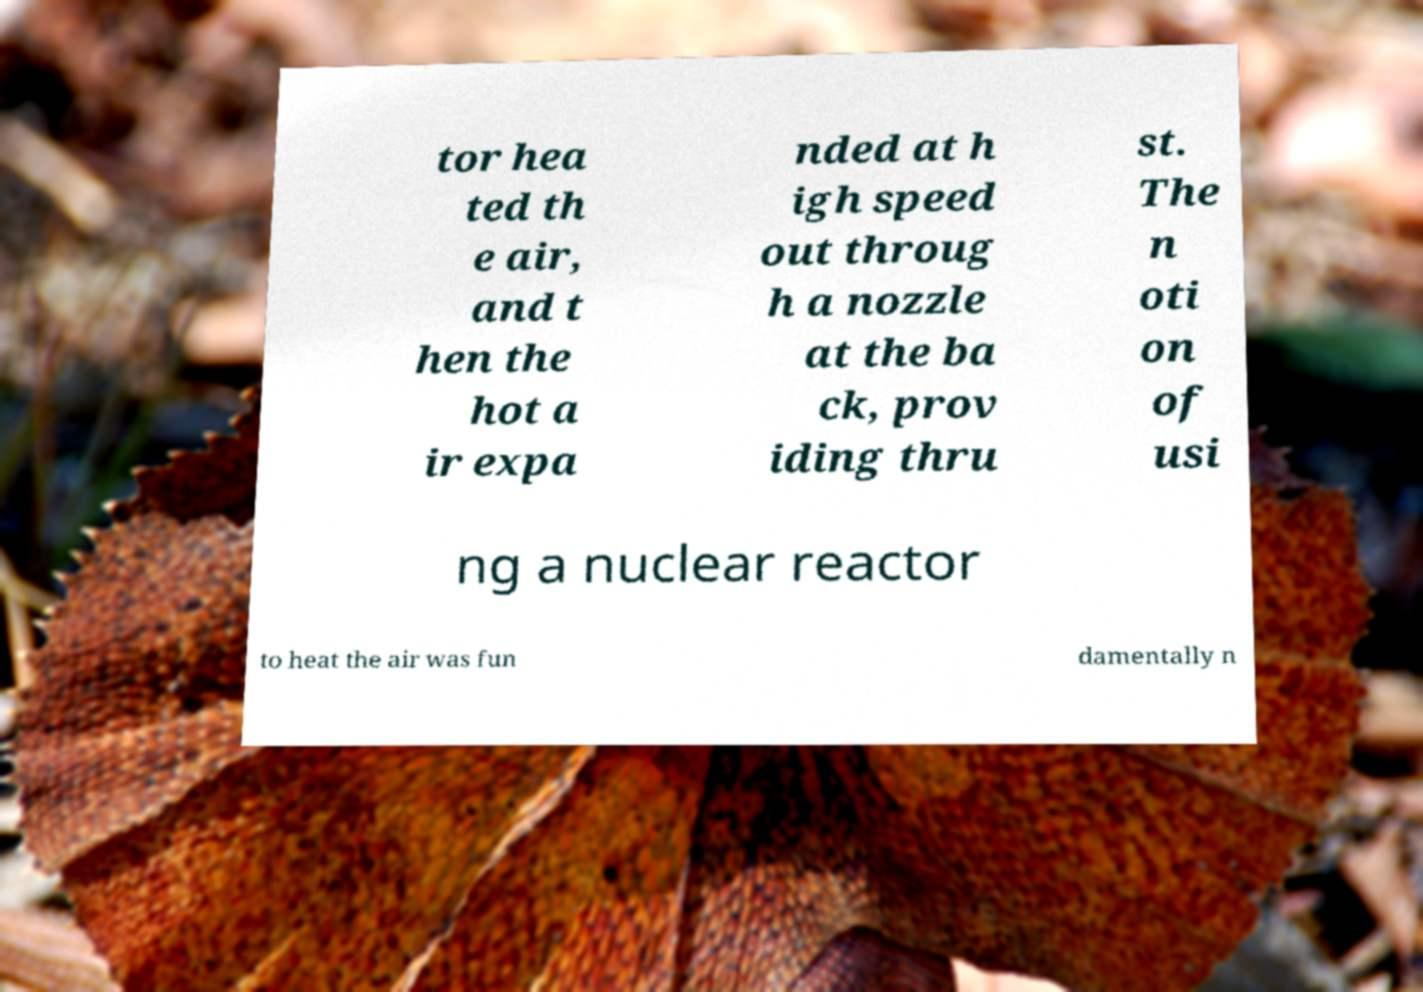Please read and relay the text visible in this image. What does it say? tor hea ted th e air, and t hen the hot a ir expa nded at h igh speed out throug h a nozzle at the ba ck, prov iding thru st. The n oti on of usi ng a nuclear reactor to heat the air was fun damentally n 